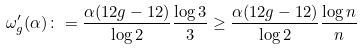<formula> <loc_0><loc_0><loc_500><loc_500>\omega ^ { \prime } _ { g } ( \alpha ) \colon = \frac { \alpha ( 1 2 g - 1 2 ) } { \log 2 } \frac { \log 3 } { 3 } \geq \frac { \alpha ( 1 2 g - 1 2 ) } { \log 2 } \frac { \log n } { n }</formula> 